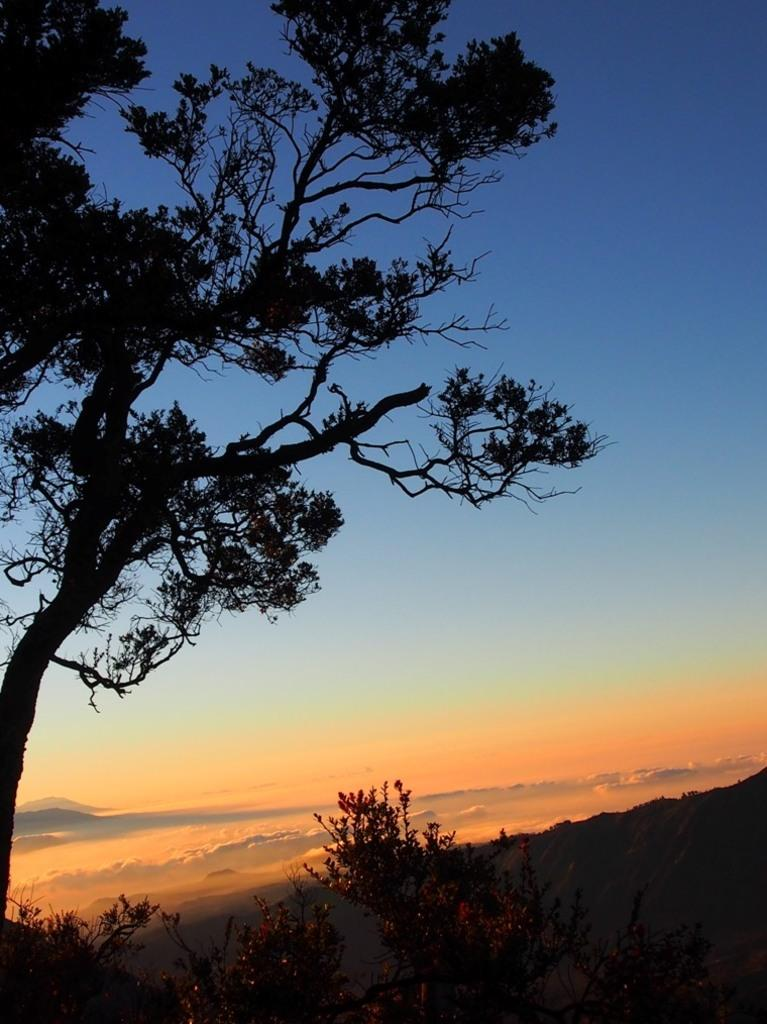What type of vegetation can be seen in the image? There are trees in the image. What type of landscape feature is present in the image? There are hills in the image. What part of the natural environment is visible in the background of the image? The sky is visible in the background of the image. How many giraffes can be seen in the image? There are no giraffes present in the image. What is the fifth element in the image? The provided facts do not mention a fifth element in the image. 